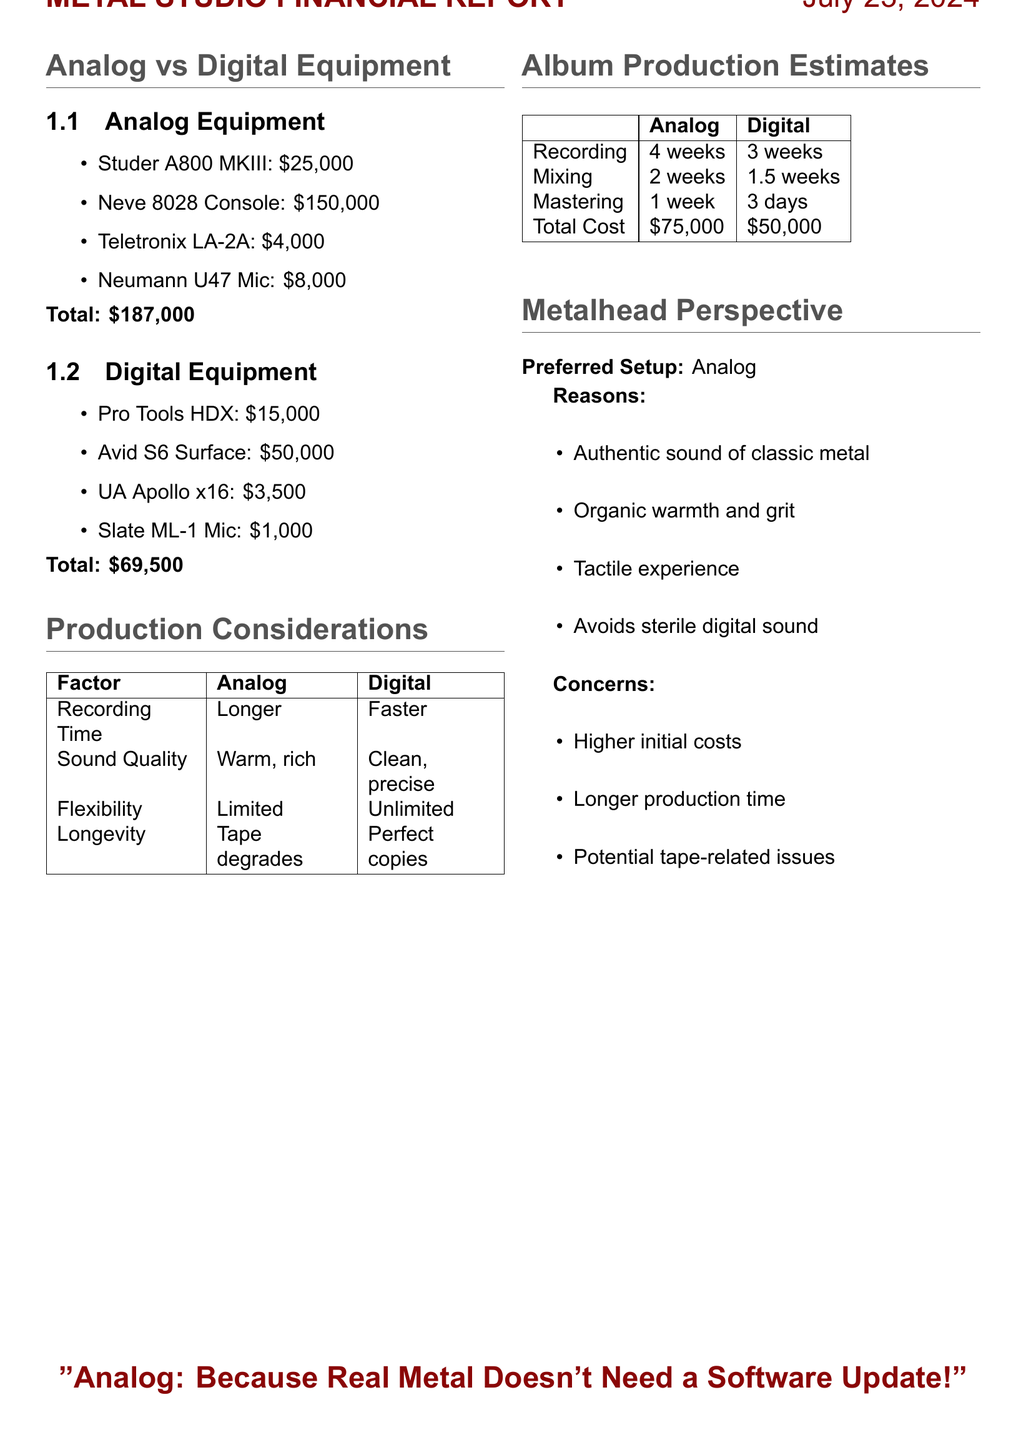What is the cost of the Studer A800 MKIII? The cost of the Studer A800 MKIII is listed in the document as $25,000.
Answer: $25,000 What is the total cost of digital equipment? The total cost of digital equipment is calculated from the prices provided in the document, which sums up to $69,500.
Answer: $69,500 What is the recording time for analog production? The document states that recording time for analog production is specified as 4 weeks.
Answer: 4 weeks Which analog equipment is preferred for its warm sound? The document describes the Studer A800 MKIII as preferred by old-school producers for its warm sound.
Answer: Studer A800 MKIII How many weeks does digital mixing take? The document indicates that digital mixing takes 1.5 weeks according to the production estimates.
Answer: 1.5 weeks What is the main concern regarding analog equipment? The document lists the higher initial equipment costs as a concern regarding analog equipment.
Answer: Higher initial equipment costs What is one benefit of digital recording mentioned in the document? According to the production considerations, one benefit of digital recording is its faster recording time compared to analog.
Answer: Faster What does the metalhead perspective prefer? The metalhead perspective clearly states a preference for analog equipment.
Answer: Analog What is a downside of digital recording as mentioned in the document? The document mentions potential format obsolescence as a downside of digital recording.
Answer: Potential format obsolescence 